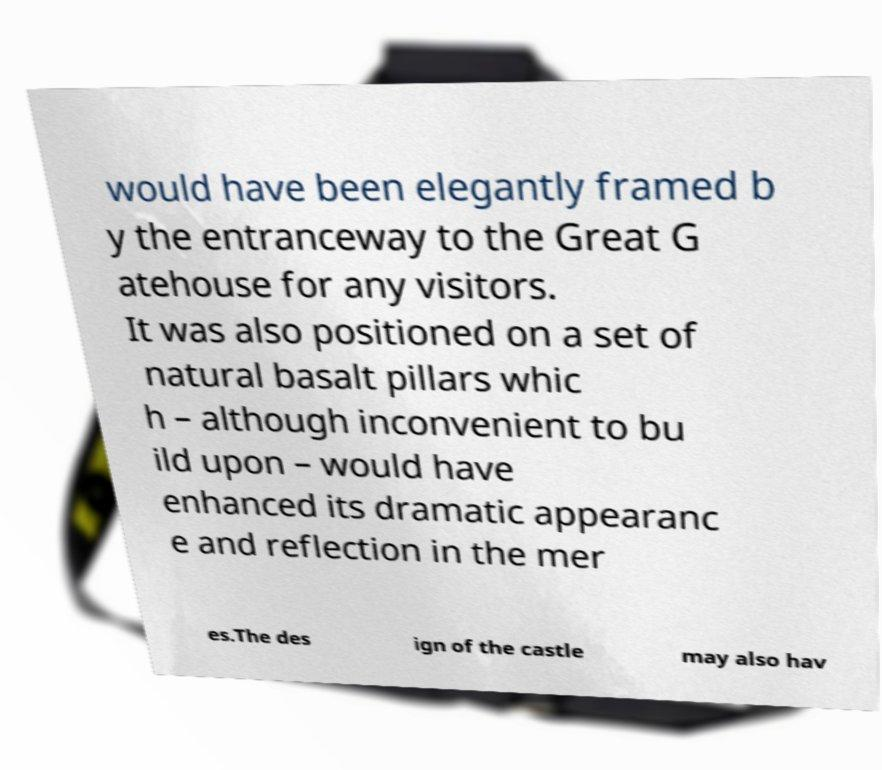There's text embedded in this image that I need extracted. Can you transcribe it verbatim? would have been elegantly framed b y the entranceway to the Great G atehouse for any visitors. It was also positioned on a set of natural basalt pillars whic h – although inconvenient to bu ild upon – would have enhanced its dramatic appearanc e and reflection in the mer es.The des ign of the castle may also hav 